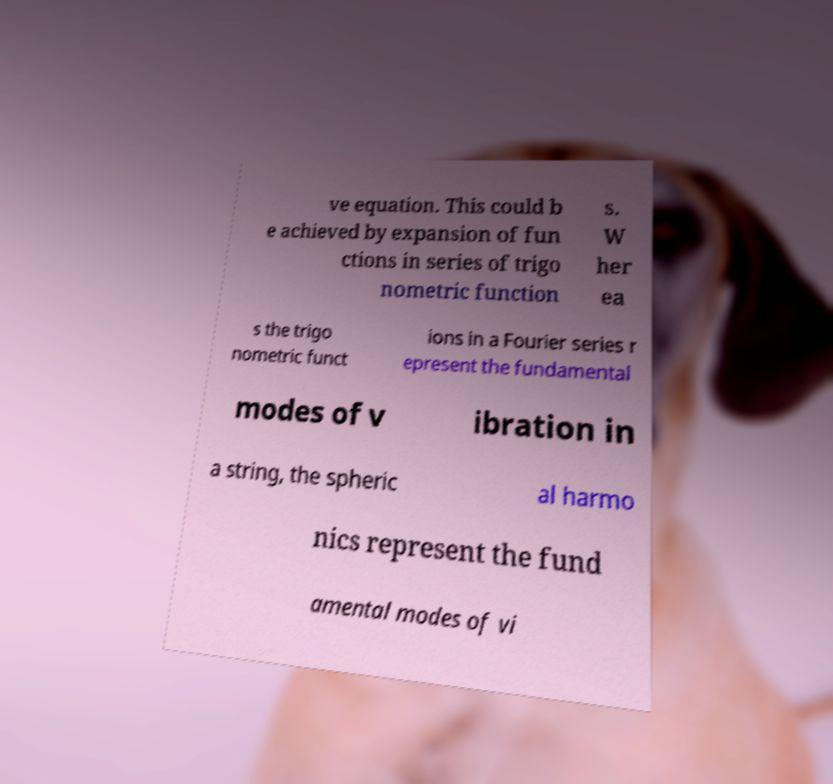What messages or text are displayed in this image? I need them in a readable, typed format. ve equation. This could b e achieved by expansion of fun ctions in series of trigo nometric function s. W her ea s the trigo nometric funct ions in a Fourier series r epresent the fundamental modes of v ibration in a string, the spheric al harmo nics represent the fund amental modes of vi 